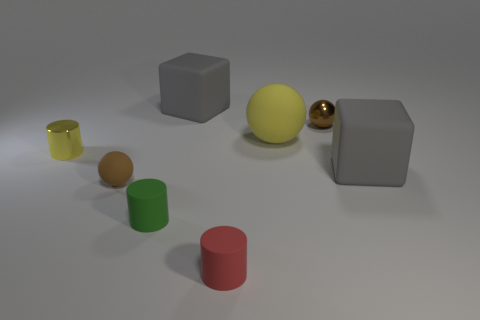There is a brown metal object; is it the same size as the gray cube that is to the left of the big yellow ball?
Provide a succinct answer. No. What size is the yellow shiny thing that is the same shape as the tiny green rubber thing?
Offer a terse response. Small. There is a big gray matte block to the right of the large gray thing on the left side of the red rubber thing; what number of gray cubes are left of it?
Ensure brevity in your answer.  1. What number of spheres are brown matte things or small green things?
Provide a succinct answer. 1. There is a tiny ball that is left of the small sphere that is behind the large cube in front of the yellow metal cylinder; what is its color?
Your answer should be compact. Brown. How many other things are the same size as the metal sphere?
Your response must be concise. 4. Is there any other thing that is the same shape as the small brown metallic thing?
Ensure brevity in your answer.  Yes. What color is the small matte thing that is the same shape as the brown shiny thing?
Offer a very short reply. Brown. The other tiny ball that is made of the same material as the yellow sphere is what color?
Provide a short and direct response. Brown. Is the number of cylinders that are on the right side of the metal sphere the same as the number of matte cubes?
Offer a terse response. No. 